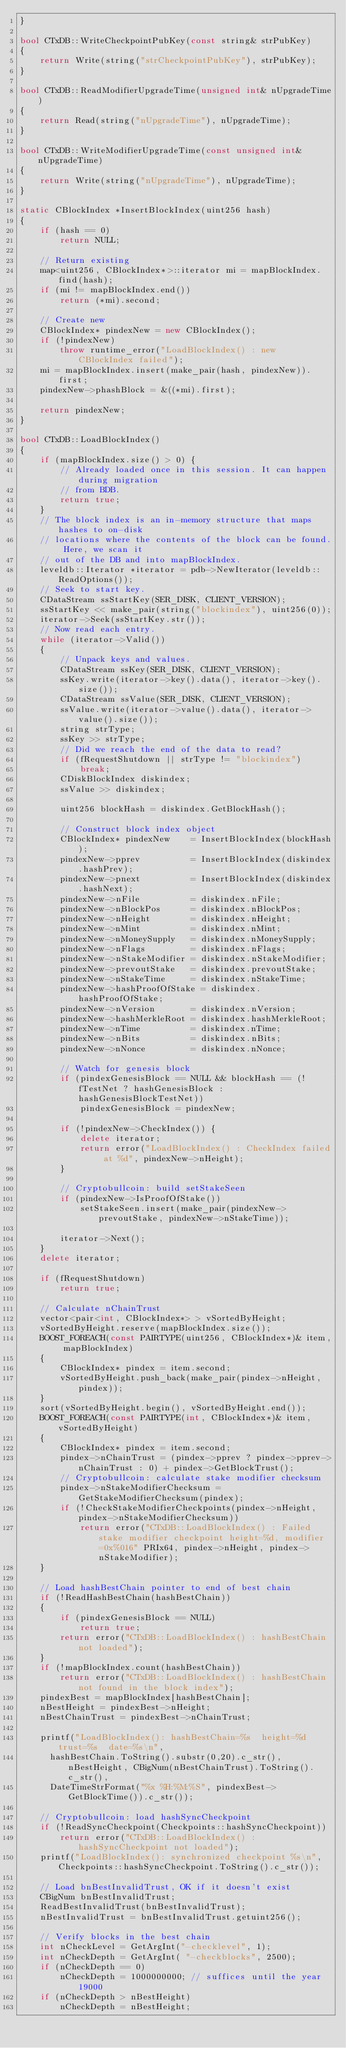<code> <loc_0><loc_0><loc_500><loc_500><_C++_>}

bool CTxDB::WriteCheckpointPubKey(const string& strPubKey)
{
    return Write(string("strCheckpointPubKey"), strPubKey);
}

bool CTxDB::ReadModifierUpgradeTime(unsigned int& nUpgradeTime)
{
    return Read(string("nUpgradeTime"), nUpgradeTime);
}

bool CTxDB::WriteModifierUpgradeTime(const unsigned int& nUpgradeTime)
{
    return Write(string("nUpgradeTime"), nUpgradeTime);
}

static CBlockIndex *InsertBlockIndex(uint256 hash)
{
    if (hash == 0)
        return NULL;

    // Return existing
    map<uint256, CBlockIndex*>::iterator mi = mapBlockIndex.find(hash);
    if (mi != mapBlockIndex.end())
        return (*mi).second;

    // Create new
    CBlockIndex* pindexNew = new CBlockIndex();
    if (!pindexNew)
        throw runtime_error("LoadBlockIndex() : new CBlockIndex failed");
    mi = mapBlockIndex.insert(make_pair(hash, pindexNew)).first;
    pindexNew->phashBlock = &((*mi).first);

    return pindexNew;
}

bool CTxDB::LoadBlockIndex()
{
    if (mapBlockIndex.size() > 0) {
        // Already loaded once in this session. It can happen during migration
        // from BDB.
        return true;
    }
    // The block index is an in-memory structure that maps hashes to on-disk
    // locations where the contents of the block can be found. Here, we scan it
    // out of the DB and into mapBlockIndex.
    leveldb::Iterator *iterator = pdb->NewIterator(leveldb::ReadOptions());
    // Seek to start key.
    CDataStream ssStartKey(SER_DISK, CLIENT_VERSION);
    ssStartKey << make_pair(string("blockindex"), uint256(0));
    iterator->Seek(ssStartKey.str());
    // Now read each entry.
    while (iterator->Valid())
    {
        // Unpack keys and values.
        CDataStream ssKey(SER_DISK, CLIENT_VERSION);
        ssKey.write(iterator->key().data(), iterator->key().size());
        CDataStream ssValue(SER_DISK, CLIENT_VERSION);
        ssValue.write(iterator->value().data(), iterator->value().size());
        string strType;
        ssKey >> strType;
        // Did we reach the end of the data to read?
        if (fRequestShutdown || strType != "blockindex")
            break;
        CDiskBlockIndex diskindex;
        ssValue >> diskindex;

        uint256 blockHash = diskindex.GetBlockHash();

        // Construct block index object
        CBlockIndex* pindexNew    = InsertBlockIndex(blockHash);
        pindexNew->pprev          = InsertBlockIndex(diskindex.hashPrev);
        pindexNew->pnext          = InsertBlockIndex(diskindex.hashNext);
        pindexNew->nFile          = diskindex.nFile;
        pindexNew->nBlockPos      = diskindex.nBlockPos;
        pindexNew->nHeight        = diskindex.nHeight;
        pindexNew->nMint          = diskindex.nMint;
        pindexNew->nMoneySupply   = diskindex.nMoneySupply;
        pindexNew->nFlags         = diskindex.nFlags;
        pindexNew->nStakeModifier = diskindex.nStakeModifier;
        pindexNew->prevoutStake   = diskindex.prevoutStake;
        pindexNew->nStakeTime     = diskindex.nStakeTime;
        pindexNew->hashProofOfStake = diskindex.hashProofOfStake;
        pindexNew->nVersion       = diskindex.nVersion;
        pindexNew->hashMerkleRoot = diskindex.hashMerkleRoot;
        pindexNew->nTime          = diskindex.nTime;
        pindexNew->nBits          = diskindex.nBits;
        pindexNew->nNonce         = diskindex.nNonce;

        // Watch for genesis block
        if (pindexGenesisBlock == NULL && blockHash == (!fTestNet ? hashGenesisBlock : hashGenesisBlockTestNet))
            pindexGenesisBlock = pindexNew;

        if (!pindexNew->CheckIndex()) {
            delete iterator;
            return error("LoadBlockIndex() : CheckIndex failed at %d", pindexNew->nHeight);
        }

        // Cryptobullcoin: build setStakeSeen
        if (pindexNew->IsProofOfStake())
            setStakeSeen.insert(make_pair(pindexNew->prevoutStake, pindexNew->nStakeTime));

        iterator->Next();
    }
    delete iterator;

    if (fRequestShutdown)
        return true;

    // Calculate nChainTrust
    vector<pair<int, CBlockIndex*> > vSortedByHeight;
    vSortedByHeight.reserve(mapBlockIndex.size());
    BOOST_FOREACH(const PAIRTYPE(uint256, CBlockIndex*)& item, mapBlockIndex)
    {
        CBlockIndex* pindex = item.second;
        vSortedByHeight.push_back(make_pair(pindex->nHeight, pindex));
    }
    sort(vSortedByHeight.begin(), vSortedByHeight.end());
    BOOST_FOREACH(const PAIRTYPE(int, CBlockIndex*)& item, vSortedByHeight)
    {
        CBlockIndex* pindex = item.second;
        pindex->nChainTrust = (pindex->pprev ? pindex->pprev->nChainTrust : 0) + pindex->GetBlockTrust();
        // Cryptobullcoin: calculate stake modifier checksum
        pindex->nStakeModifierChecksum = GetStakeModifierChecksum(pindex);
        if (!CheckStakeModifierCheckpoints(pindex->nHeight, pindex->nStakeModifierChecksum))
            return error("CTxDB::LoadBlockIndex() : Failed stake modifier checkpoint height=%d, modifier=0x%016" PRIx64, pindex->nHeight, pindex->nStakeModifier);
    }

    // Load hashBestChain pointer to end of best chain
    if (!ReadHashBestChain(hashBestChain))
    {
        if (pindexGenesisBlock == NULL)
            return true;
        return error("CTxDB::LoadBlockIndex() : hashBestChain not loaded");
    }
    if (!mapBlockIndex.count(hashBestChain))
        return error("CTxDB::LoadBlockIndex() : hashBestChain not found in the block index");
    pindexBest = mapBlockIndex[hashBestChain];
    nBestHeight = pindexBest->nHeight;
    nBestChainTrust = pindexBest->nChainTrust;

    printf("LoadBlockIndex(): hashBestChain=%s  height=%d  trust=%s  date=%s\n",
      hashBestChain.ToString().substr(0,20).c_str(), nBestHeight, CBigNum(nBestChainTrust).ToString().c_str(),
      DateTimeStrFormat("%x %H:%M:%S", pindexBest->GetBlockTime()).c_str());

    // Cryptobullcoin: load hashSyncCheckpoint
    if (!ReadSyncCheckpoint(Checkpoints::hashSyncCheckpoint))
        return error("CTxDB::LoadBlockIndex() : hashSyncCheckpoint not loaded");
    printf("LoadBlockIndex(): synchronized checkpoint %s\n", Checkpoints::hashSyncCheckpoint.ToString().c_str());

    // Load bnBestInvalidTrust, OK if it doesn't exist
    CBigNum bnBestInvalidTrust;
    ReadBestInvalidTrust(bnBestInvalidTrust);
    nBestInvalidTrust = bnBestInvalidTrust.getuint256();

    // Verify blocks in the best chain
    int nCheckLevel = GetArgInt("-checklevel", 1);
    int nCheckDepth = GetArgInt( "-checkblocks", 2500);
    if (nCheckDepth == 0)
        nCheckDepth = 1000000000; // suffices until the year 19000
    if (nCheckDepth > nBestHeight)
        nCheckDepth = nBestHeight;</code> 